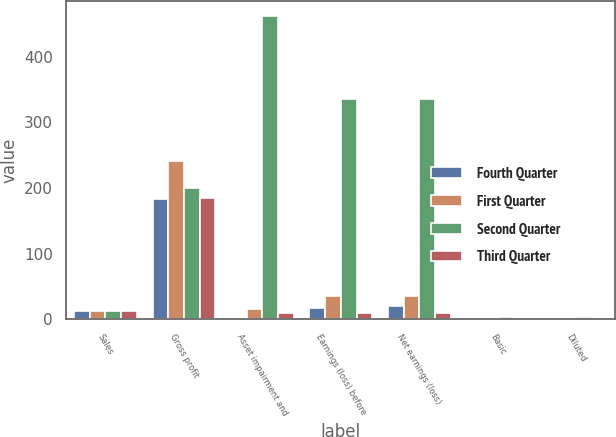Convert chart to OTSL. <chart><loc_0><loc_0><loc_500><loc_500><stacked_bar_chart><ecel><fcel>Sales<fcel>Gross profit<fcel>Asset impairment and<fcel>Earnings (loss) before<fcel>Net earnings (loss)<fcel>Basic<fcel>Diluted<nl><fcel>Fourth Quarter<fcel>13<fcel>184<fcel>2<fcel>18<fcel>21<fcel>0.23<fcel>0.23<nl><fcel>First Quarter<fcel>13<fcel>241<fcel>16<fcel>35<fcel>35<fcel>0.46<fcel>0.46<nl><fcel>Second Quarter<fcel>13<fcel>200<fcel>462<fcel>336<fcel>336<fcel>4.35<fcel>4.35<nl><fcel>Third Quarter<fcel>13<fcel>185<fcel>9<fcel>10<fcel>10<fcel>0.13<fcel>0.13<nl></chart> 